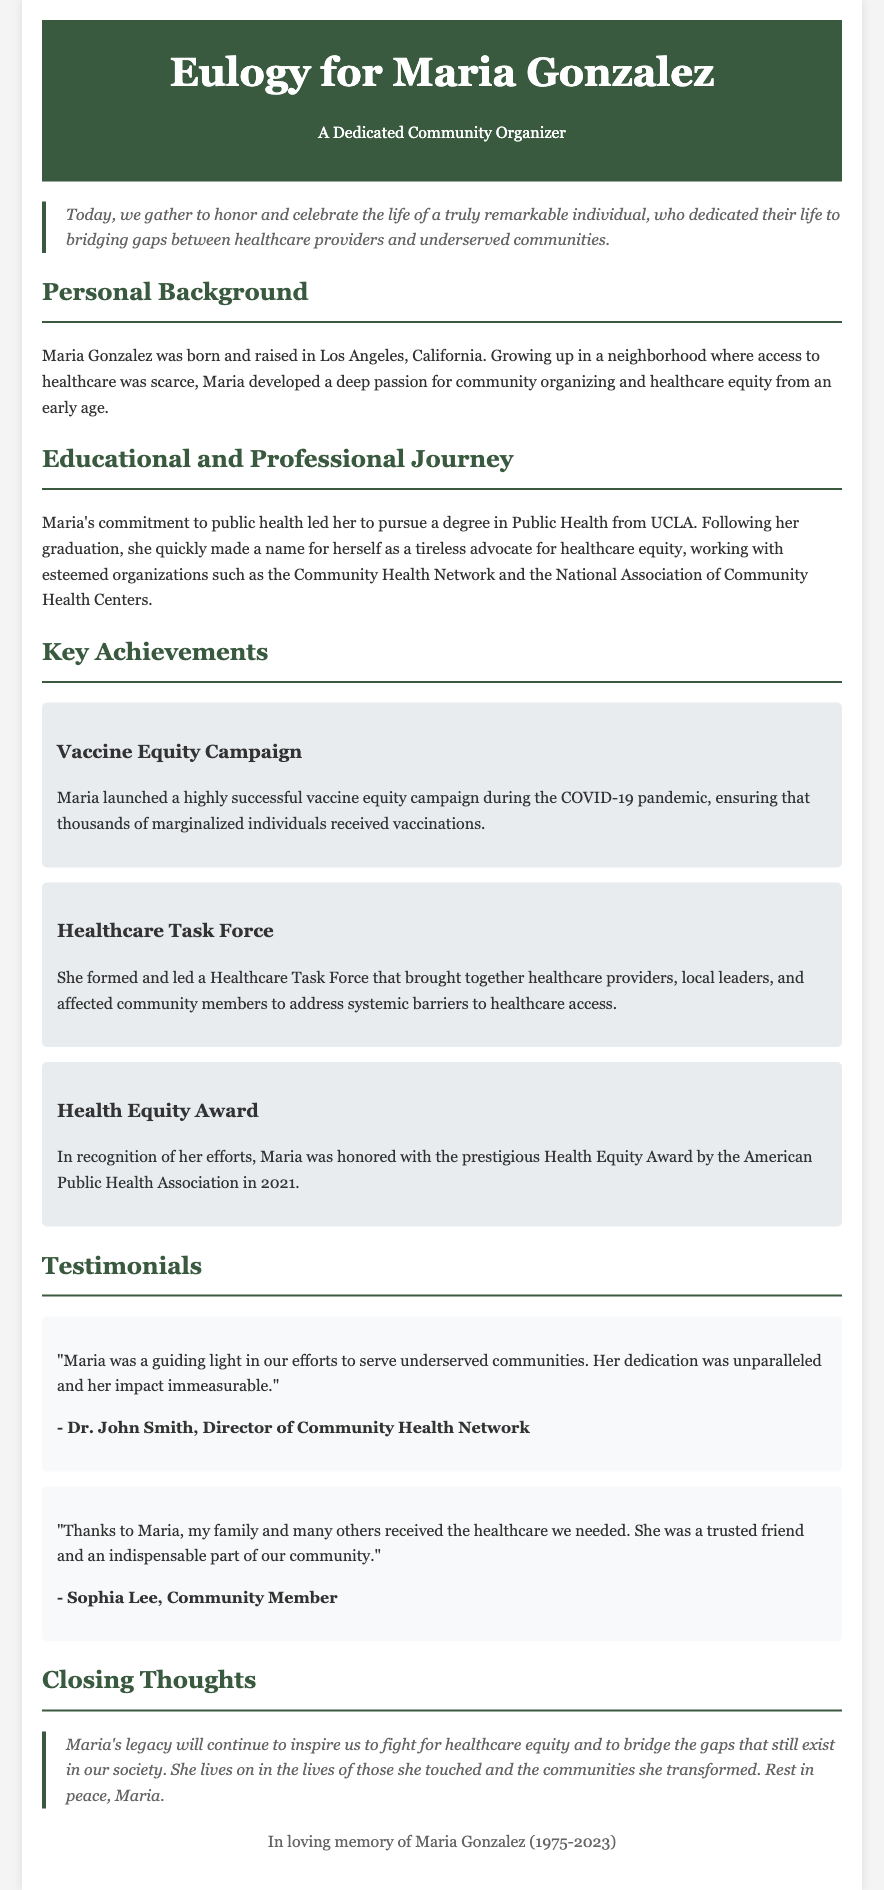What was Maria Gonzalez's profession? The document describes her as a dedicated community organizer.
Answer: Community Organizer Where was Maria Gonzalez born? The document states she was born and raised in Los Angeles, California.
Answer: Los Angeles What degree did Maria obtain? The document mentions that she pursued a degree in Public Health from UCLA.
Answer: Public Health What year did Maria receive the Health Equity Award? The document specifies that she was honored with the award in 2021.
Answer: 2021 What was the main focus of the vaccine equity campaign launched by Maria? The document highlights that it ensured thousands of marginalized individuals received vaccinations.
Answer: Vaccinations Who is quoted as stating Maria's dedication was unparalleled? The document attributes this quote to Dr. John Smith, Director of Community Health Network.
Answer: Dr. John Smith What was one of the key initiatives created by Maria? The document mentions she formed a Healthcare Task Force to address systemic barriers.
Answer: Healthcare Task Force How does the document describe Maria's legacy? The document states that her legacy will continue to inspire the fight for healthcare equity.
Answer: Inspire the fight for healthcare equity 